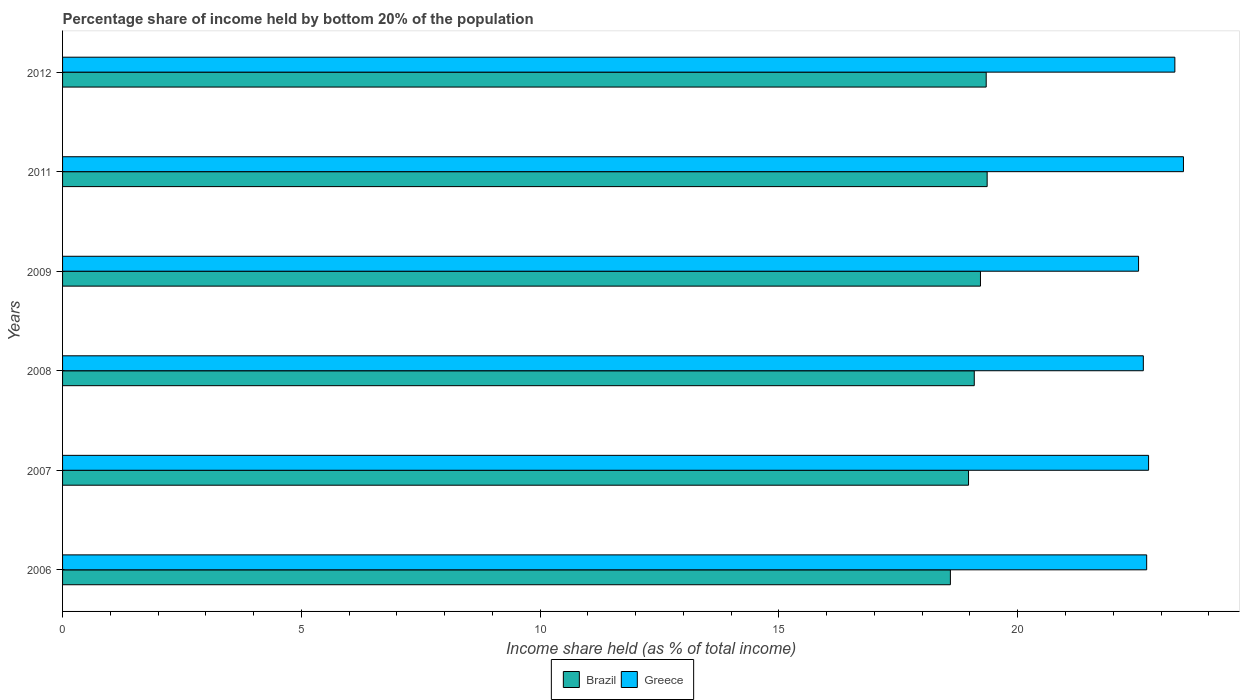How many groups of bars are there?
Offer a very short reply. 6. Are the number of bars on each tick of the Y-axis equal?
Make the answer very short. Yes. What is the share of income held by bottom 20% of the population in Brazil in 2009?
Keep it short and to the point. 19.22. Across all years, what is the maximum share of income held by bottom 20% of the population in Brazil?
Keep it short and to the point. 19.36. Across all years, what is the minimum share of income held by bottom 20% of the population in Greece?
Your answer should be very brief. 22.53. In which year was the share of income held by bottom 20% of the population in Greece maximum?
Provide a short and direct response. 2011. In which year was the share of income held by bottom 20% of the population in Brazil minimum?
Your answer should be very brief. 2006. What is the total share of income held by bottom 20% of the population in Brazil in the graph?
Make the answer very short. 114.57. What is the difference between the share of income held by bottom 20% of the population in Brazil in 2011 and that in 2012?
Provide a short and direct response. 0.02. What is the difference between the share of income held by bottom 20% of the population in Brazil in 2006 and the share of income held by bottom 20% of the population in Greece in 2011?
Offer a terse response. -4.88. What is the average share of income held by bottom 20% of the population in Brazil per year?
Offer a terse response. 19.1. In the year 2012, what is the difference between the share of income held by bottom 20% of the population in Greece and share of income held by bottom 20% of the population in Brazil?
Make the answer very short. 3.95. In how many years, is the share of income held by bottom 20% of the population in Brazil greater than 19 %?
Keep it short and to the point. 4. What is the ratio of the share of income held by bottom 20% of the population in Brazil in 2007 to that in 2011?
Offer a very short reply. 0.98. Is the share of income held by bottom 20% of the population in Brazil in 2007 less than that in 2012?
Offer a very short reply. Yes. What is the difference between the highest and the second highest share of income held by bottom 20% of the population in Greece?
Offer a terse response. 0.18. What is the difference between the highest and the lowest share of income held by bottom 20% of the population in Brazil?
Keep it short and to the point. 0.77. In how many years, is the share of income held by bottom 20% of the population in Brazil greater than the average share of income held by bottom 20% of the population in Brazil taken over all years?
Provide a succinct answer. 3. How many bars are there?
Offer a very short reply. 12. Are all the bars in the graph horizontal?
Your answer should be compact. Yes. Does the graph contain any zero values?
Keep it short and to the point. No. Does the graph contain grids?
Your answer should be compact. No. Where does the legend appear in the graph?
Keep it short and to the point. Bottom center. What is the title of the graph?
Make the answer very short. Percentage share of income held by bottom 20% of the population. What is the label or title of the X-axis?
Make the answer very short. Income share held (as % of total income). What is the label or title of the Y-axis?
Offer a terse response. Years. What is the Income share held (as % of total income) in Brazil in 2006?
Offer a very short reply. 18.59. What is the Income share held (as % of total income) of Greece in 2006?
Your answer should be very brief. 22.7. What is the Income share held (as % of total income) in Brazil in 2007?
Your response must be concise. 18.97. What is the Income share held (as % of total income) in Greece in 2007?
Offer a terse response. 22.74. What is the Income share held (as % of total income) in Brazil in 2008?
Your response must be concise. 19.09. What is the Income share held (as % of total income) in Greece in 2008?
Give a very brief answer. 22.63. What is the Income share held (as % of total income) in Brazil in 2009?
Provide a short and direct response. 19.22. What is the Income share held (as % of total income) of Greece in 2009?
Offer a very short reply. 22.53. What is the Income share held (as % of total income) in Brazil in 2011?
Your answer should be very brief. 19.36. What is the Income share held (as % of total income) in Greece in 2011?
Offer a very short reply. 23.47. What is the Income share held (as % of total income) of Brazil in 2012?
Your response must be concise. 19.34. What is the Income share held (as % of total income) of Greece in 2012?
Offer a terse response. 23.29. Across all years, what is the maximum Income share held (as % of total income) of Brazil?
Your response must be concise. 19.36. Across all years, what is the maximum Income share held (as % of total income) in Greece?
Your answer should be very brief. 23.47. Across all years, what is the minimum Income share held (as % of total income) of Brazil?
Your response must be concise. 18.59. Across all years, what is the minimum Income share held (as % of total income) in Greece?
Your answer should be very brief. 22.53. What is the total Income share held (as % of total income) in Brazil in the graph?
Make the answer very short. 114.57. What is the total Income share held (as % of total income) of Greece in the graph?
Provide a succinct answer. 137.36. What is the difference between the Income share held (as % of total income) in Brazil in 2006 and that in 2007?
Your answer should be compact. -0.38. What is the difference between the Income share held (as % of total income) in Greece in 2006 and that in 2007?
Your response must be concise. -0.04. What is the difference between the Income share held (as % of total income) in Brazil in 2006 and that in 2008?
Your response must be concise. -0.5. What is the difference between the Income share held (as % of total income) in Greece in 2006 and that in 2008?
Give a very brief answer. 0.07. What is the difference between the Income share held (as % of total income) in Brazil in 2006 and that in 2009?
Keep it short and to the point. -0.63. What is the difference between the Income share held (as % of total income) in Greece in 2006 and that in 2009?
Provide a succinct answer. 0.17. What is the difference between the Income share held (as % of total income) of Brazil in 2006 and that in 2011?
Provide a short and direct response. -0.77. What is the difference between the Income share held (as % of total income) in Greece in 2006 and that in 2011?
Provide a short and direct response. -0.77. What is the difference between the Income share held (as % of total income) of Brazil in 2006 and that in 2012?
Give a very brief answer. -0.75. What is the difference between the Income share held (as % of total income) of Greece in 2006 and that in 2012?
Your answer should be compact. -0.59. What is the difference between the Income share held (as % of total income) of Brazil in 2007 and that in 2008?
Ensure brevity in your answer.  -0.12. What is the difference between the Income share held (as % of total income) of Greece in 2007 and that in 2008?
Ensure brevity in your answer.  0.11. What is the difference between the Income share held (as % of total income) of Brazil in 2007 and that in 2009?
Your response must be concise. -0.25. What is the difference between the Income share held (as % of total income) in Greece in 2007 and that in 2009?
Provide a short and direct response. 0.21. What is the difference between the Income share held (as % of total income) in Brazil in 2007 and that in 2011?
Your response must be concise. -0.39. What is the difference between the Income share held (as % of total income) in Greece in 2007 and that in 2011?
Keep it short and to the point. -0.73. What is the difference between the Income share held (as % of total income) of Brazil in 2007 and that in 2012?
Keep it short and to the point. -0.37. What is the difference between the Income share held (as % of total income) of Greece in 2007 and that in 2012?
Keep it short and to the point. -0.55. What is the difference between the Income share held (as % of total income) in Brazil in 2008 and that in 2009?
Offer a terse response. -0.13. What is the difference between the Income share held (as % of total income) in Brazil in 2008 and that in 2011?
Give a very brief answer. -0.27. What is the difference between the Income share held (as % of total income) in Greece in 2008 and that in 2011?
Your answer should be very brief. -0.84. What is the difference between the Income share held (as % of total income) in Brazil in 2008 and that in 2012?
Ensure brevity in your answer.  -0.25. What is the difference between the Income share held (as % of total income) of Greece in 2008 and that in 2012?
Provide a succinct answer. -0.66. What is the difference between the Income share held (as % of total income) in Brazil in 2009 and that in 2011?
Give a very brief answer. -0.14. What is the difference between the Income share held (as % of total income) in Greece in 2009 and that in 2011?
Offer a very short reply. -0.94. What is the difference between the Income share held (as % of total income) in Brazil in 2009 and that in 2012?
Offer a very short reply. -0.12. What is the difference between the Income share held (as % of total income) of Greece in 2009 and that in 2012?
Provide a short and direct response. -0.76. What is the difference between the Income share held (as % of total income) in Greece in 2011 and that in 2012?
Your answer should be compact. 0.18. What is the difference between the Income share held (as % of total income) in Brazil in 2006 and the Income share held (as % of total income) in Greece in 2007?
Provide a short and direct response. -4.15. What is the difference between the Income share held (as % of total income) of Brazil in 2006 and the Income share held (as % of total income) of Greece in 2008?
Offer a terse response. -4.04. What is the difference between the Income share held (as % of total income) of Brazil in 2006 and the Income share held (as % of total income) of Greece in 2009?
Provide a succinct answer. -3.94. What is the difference between the Income share held (as % of total income) of Brazil in 2006 and the Income share held (as % of total income) of Greece in 2011?
Provide a short and direct response. -4.88. What is the difference between the Income share held (as % of total income) of Brazil in 2007 and the Income share held (as % of total income) of Greece in 2008?
Give a very brief answer. -3.66. What is the difference between the Income share held (as % of total income) of Brazil in 2007 and the Income share held (as % of total income) of Greece in 2009?
Your answer should be compact. -3.56. What is the difference between the Income share held (as % of total income) in Brazil in 2007 and the Income share held (as % of total income) in Greece in 2011?
Ensure brevity in your answer.  -4.5. What is the difference between the Income share held (as % of total income) of Brazil in 2007 and the Income share held (as % of total income) of Greece in 2012?
Offer a terse response. -4.32. What is the difference between the Income share held (as % of total income) of Brazil in 2008 and the Income share held (as % of total income) of Greece in 2009?
Your response must be concise. -3.44. What is the difference between the Income share held (as % of total income) in Brazil in 2008 and the Income share held (as % of total income) in Greece in 2011?
Provide a short and direct response. -4.38. What is the difference between the Income share held (as % of total income) of Brazil in 2009 and the Income share held (as % of total income) of Greece in 2011?
Provide a short and direct response. -4.25. What is the difference between the Income share held (as % of total income) of Brazil in 2009 and the Income share held (as % of total income) of Greece in 2012?
Keep it short and to the point. -4.07. What is the difference between the Income share held (as % of total income) of Brazil in 2011 and the Income share held (as % of total income) of Greece in 2012?
Provide a short and direct response. -3.93. What is the average Income share held (as % of total income) in Brazil per year?
Offer a very short reply. 19.09. What is the average Income share held (as % of total income) in Greece per year?
Offer a terse response. 22.89. In the year 2006, what is the difference between the Income share held (as % of total income) in Brazil and Income share held (as % of total income) in Greece?
Provide a short and direct response. -4.11. In the year 2007, what is the difference between the Income share held (as % of total income) in Brazil and Income share held (as % of total income) in Greece?
Provide a short and direct response. -3.77. In the year 2008, what is the difference between the Income share held (as % of total income) of Brazil and Income share held (as % of total income) of Greece?
Your answer should be very brief. -3.54. In the year 2009, what is the difference between the Income share held (as % of total income) of Brazil and Income share held (as % of total income) of Greece?
Offer a very short reply. -3.31. In the year 2011, what is the difference between the Income share held (as % of total income) of Brazil and Income share held (as % of total income) of Greece?
Your response must be concise. -4.11. In the year 2012, what is the difference between the Income share held (as % of total income) of Brazil and Income share held (as % of total income) of Greece?
Keep it short and to the point. -3.95. What is the ratio of the Income share held (as % of total income) of Brazil in 2006 to that in 2007?
Provide a short and direct response. 0.98. What is the ratio of the Income share held (as % of total income) in Brazil in 2006 to that in 2008?
Provide a succinct answer. 0.97. What is the ratio of the Income share held (as % of total income) in Greece in 2006 to that in 2008?
Make the answer very short. 1. What is the ratio of the Income share held (as % of total income) of Brazil in 2006 to that in 2009?
Offer a terse response. 0.97. What is the ratio of the Income share held (as % of total income) of Greece in 2006 to that in 2009?
Make the answer very short. 1.01. What is the ratio of the Income share held (as % of total income) in Brazil in 2006 to that in 2011?
Make the answer very short. 0.96. What is the ratio of the Income share held (as % of total income) in Greece in 2006 to that in 2011?
Offer a terse response. 0.97. What is the ratio of the Income share held (as % of total income) in Brazil in 2006 to that in 2012?
Offer a terse response. 0.96. What is the ratio of the Income share held (as % of total income) in Greece in 2006 to that in 2012?
Give a very brief answer. 0.97. What is the ratio of the Income share held (as % of total income) in Greece in 2007 to that in 2009?
Your response must be concise. 1.01. What is the ratio of the Income share held (as % of total income) in Brazil in 2007 to that in 2011?
Provide a short and direct response. 0.98. What is the ratio of the Income share held (as % of total income) in Greece in 2007 to that in 2011?
Keep it short and to the point. 0.97. What is the ratio of the Income share held (as % of total income) in Brazil in 2007 to that in 2012?
Offer a very short reply. 0.98. What is the ratio of the Income share held (as % of total income) of Greece in 2007 to that in 2012?
Give a very brief answer. 0.98. What is the ratio of the Income share held (as % of total income) in Brazil in 2008 to that in 2009?
Ensure brevity in your answer.  0.99. What is the ratio of the Income share held (as % of total income) in Brazil in 2008 to that in 2011?
Ensure brevity in your answer.  0.99. What is the ratio of the Income share held (as % of total income) of Greece in 2008 to that in 2011?
Offer a very short reply. 0.96. What is the ratio of the Income share held (as % of total income) of Brazil in 2008 to that in 2012?
Provide a short and direct response. 0.99. What is the ratio of the Income share held (as % of total income) in Greece in 2008 to that in 2012?
Offer a very short reply. 0.97. What is the ratio of the Income share held (as % of total income) of Brazil in 2009 to that in 2011?
Provide a short and direct response. 0.99. What is the ratio of the Income share held (as % of total income) of Greece in 2009 to that in 2011?
Provide a succinct answer. 0.96. What is the ratio of the Income share held (as % of total income) of Brazil in 2009 to that in 2012?
Keep it short and to the point. 0.99. What is the ratio of the Income share held (as % of total income) in Greece in 2009 to that in 2012?
Your answer should be very brief. 0.97. What is the ratio of the Income share held (as % of total income) of Brazil in 2011 to that in 2012?
Offer a terse response. 1. What is the ratio of the Income share held (as % of total income) in Greece in 2011 to that in 2012?
Your answer should be compact. 1.01. What is the difference between the highest and the second highest Income share held (as % of total income) of Brazil?
Give a very brief answer. 0.02. What is the difference between the highest and the second highest Income share held (as % of total income) in Greece?
Give a very brief answer. 0.18. What is the difference between the highest and the lowest Income share held (as % of total income) of Brazil?
Provide a short and direct response. 0.77. 